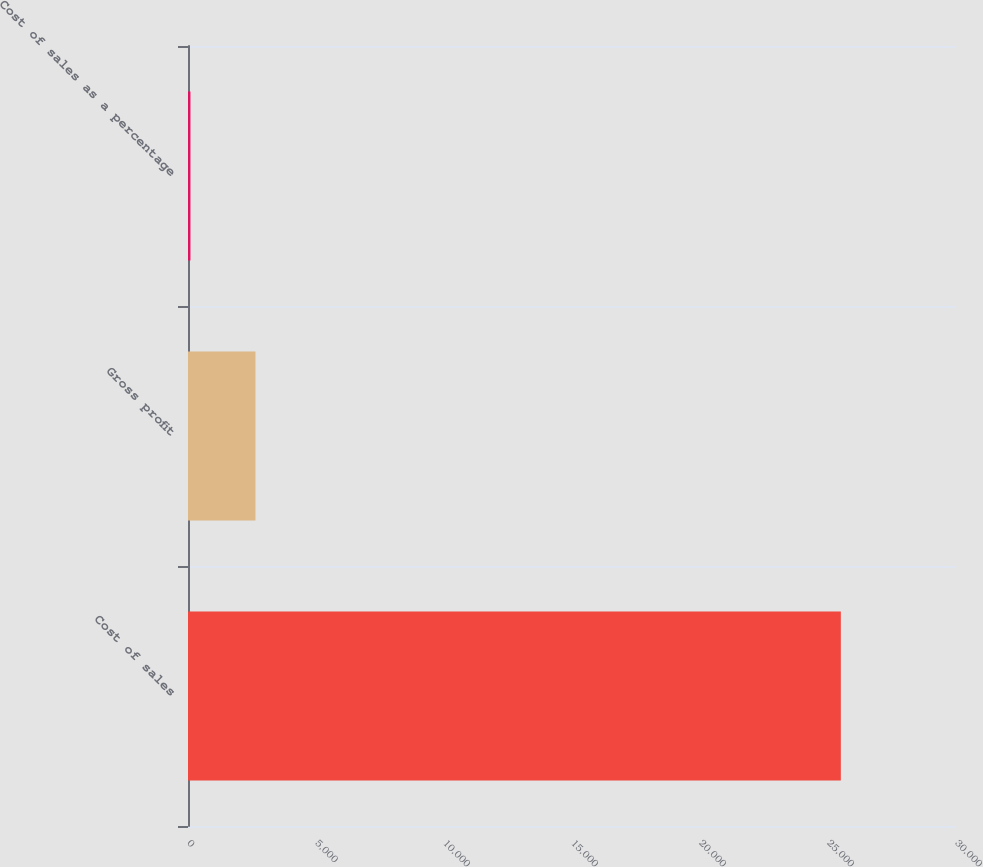<chart> <loc_0><loc_0><loc_500><loc_500><bar_chart><fcel>Cost of sales<fcel>Gross profit<fcel>Cost of sales as a percentage<nl><fcel>25501<fcel>2636.05<fcel>95.5<nl></chart> 